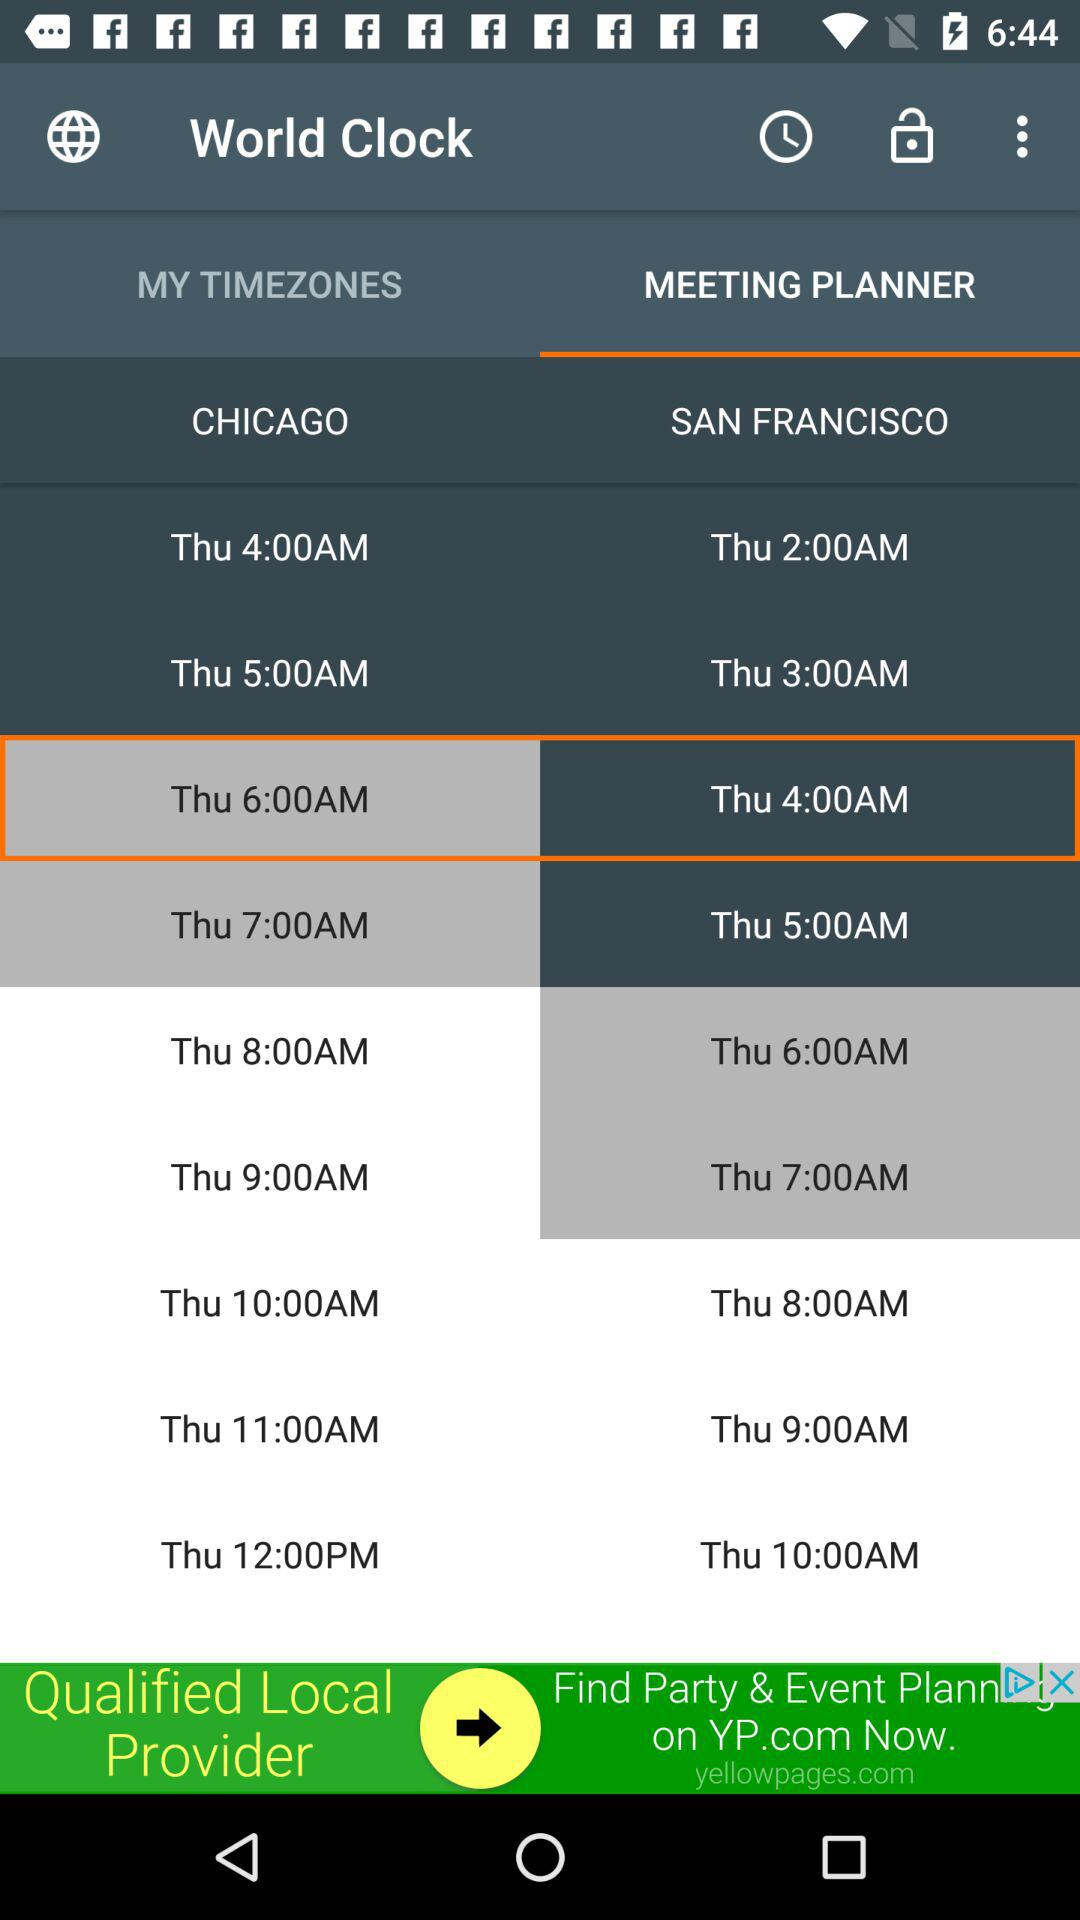Time Zone of which two countries are compared? Time Zone of "CHICAGO" and "SAN FRANCISCO" are compared. 